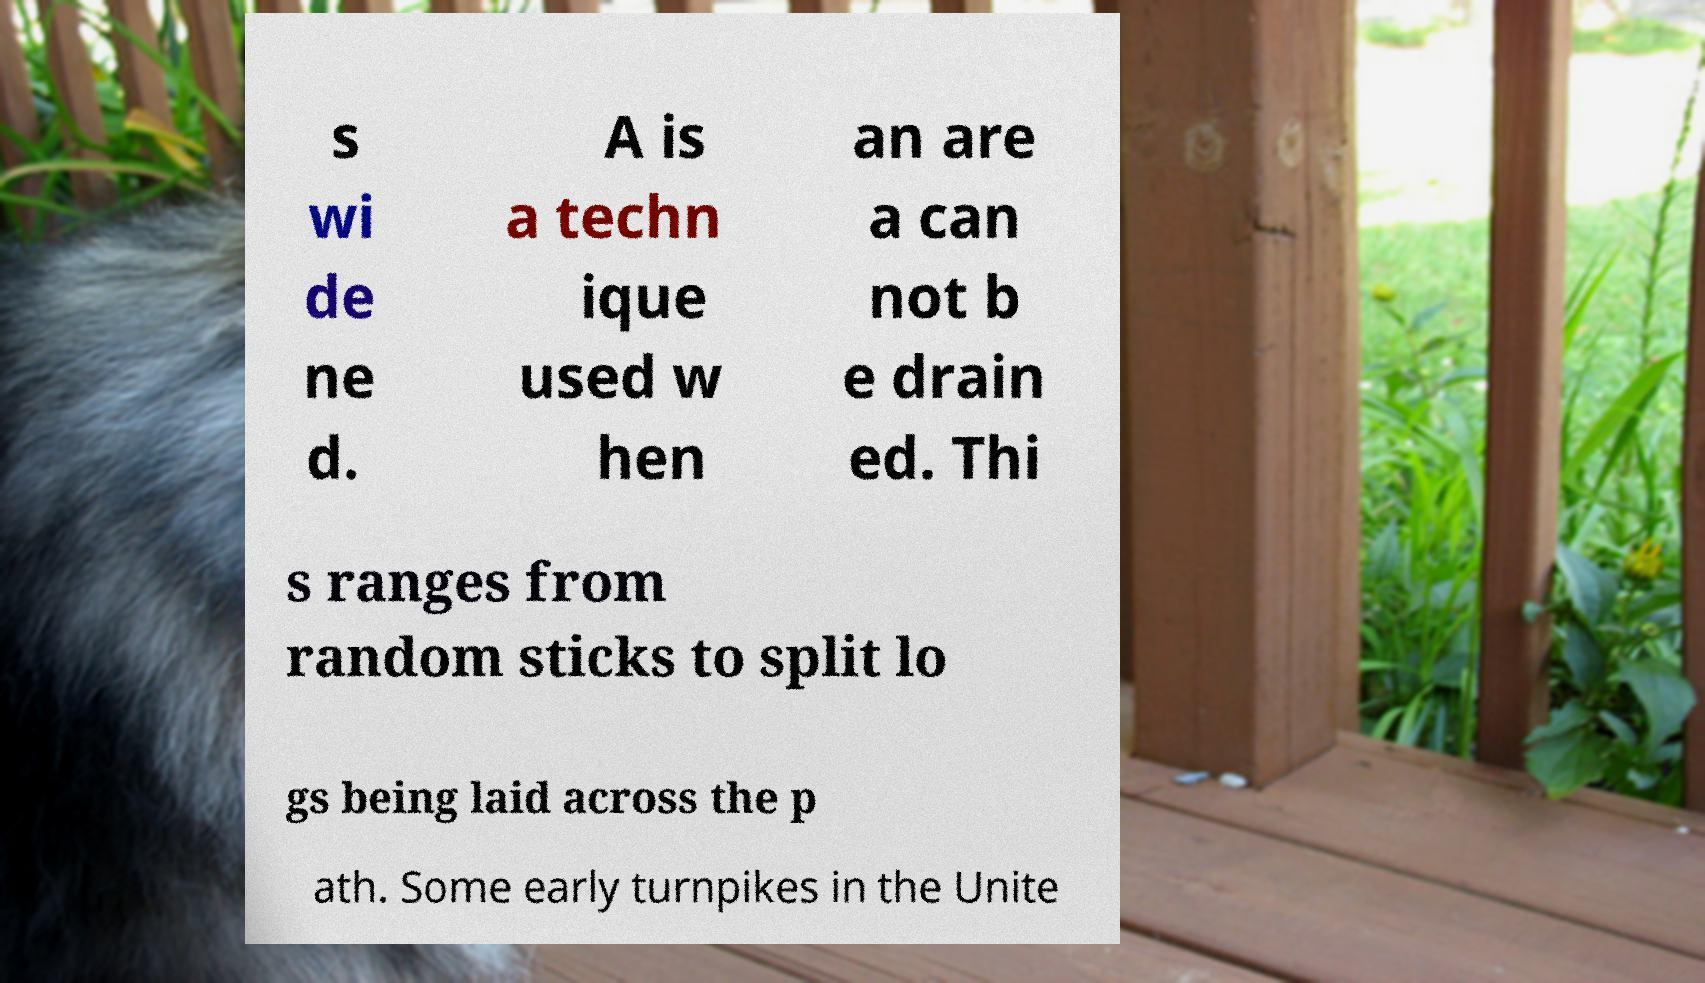Could you assist in decoding the text presented in this image and type it out clearly? s wi de ne d. A is a techn ique used w hen an are a can not b e drain ed. Thi s ranges from random sticks to split lo gs being laid across the p ath. Some early turnpikes in the Unite 